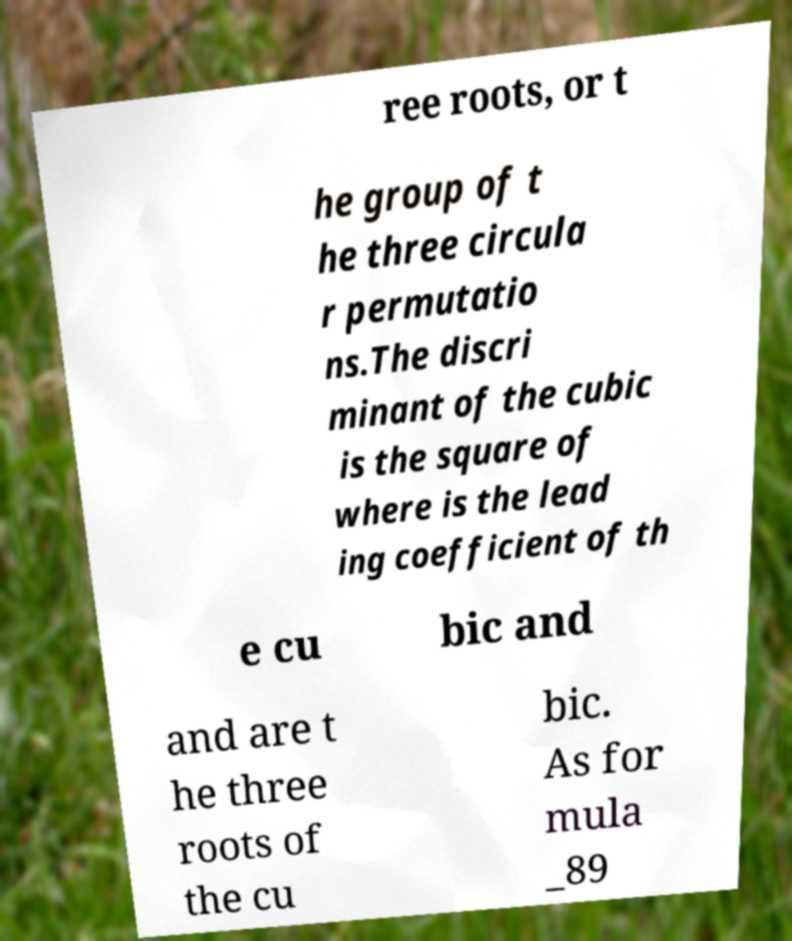There's text embedded in this image that I need extracted. Can you transcribe it verbatim? ree roots, or t he group of t he three circula r permutatio ns.The discri minant of the cubic is the square of where is the lead ing coefficient of th e cu bic and and are t he three roots of the cu bic. As for mula _89 